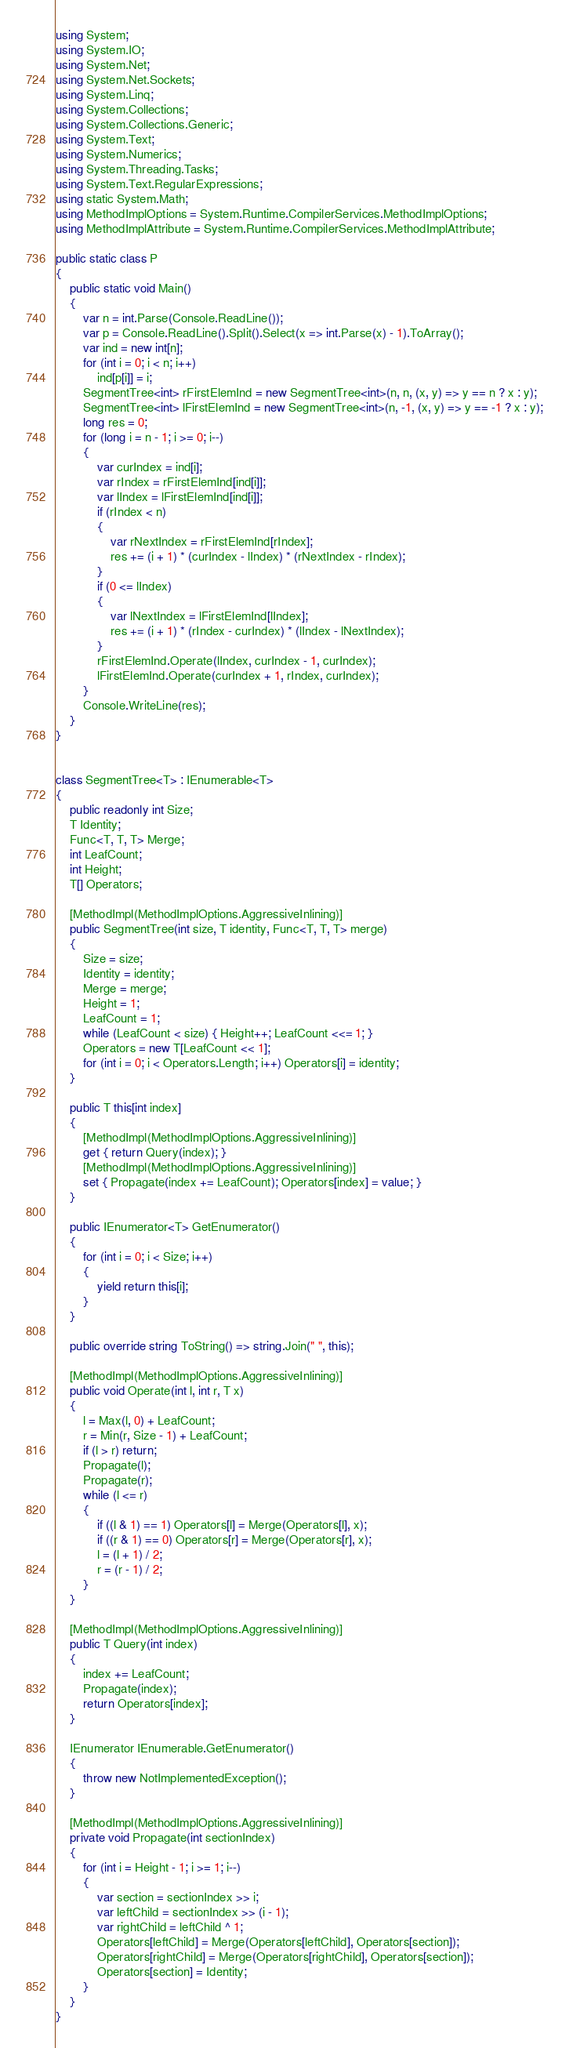Convert code to text. <code><loc_0><loc_0><loc_500><loc_500><_C#_>using System;
using System.IO;
using System.Net;
using System.Net.Sockets;
using System.Linq;
using System.Collections;
using System.Collections.Generic;
using System.Text;
using System.Numerics;
using System.Threading.Tasks;
using System.Text.RegularExpressions;
using static System.Math;
using MethodImplOptions = System.Runtime.CompilerServices.MethodImplOptions;
using MethodImplAttribute = System.Runtime.CompilerServices.MethodImplAttribute;

public static class P
{
    public static void Main()
    {
        var n = int.Parse(Console.ReadLine());
        var p = Console.ReadLine().Split().Select(x => int.Parse(x) - 1).ToArray();
        var ind = new int[n];
        for (int i = 0; i < n; i++)
            ind[p[i]] = i;
        SegmentTree<int> rFirstElemInd = new SegmentTree<int>(n, n, (x, y) => y == n ? x : y);
        SegmentTree<int> lFirstElemInd = new SegmentTree<int>(n, -1, (x, y) => y == -1 ? x : y);
        long res = 0;
        for (long i = n - 1; i >= 0; i--)
        {
            var curIndex = ind[i];
            var rIndex = rFirstElemInd[ind[i]];
            var lIndex = lFirstElemInd[ind[i]];
            if (rIndex < n)
            {
                var rNextIndex = rFirstElemInd[rIndex];
                res += (i + 1) * (curIndex - lIndex) * (rNextIndex - rIndex);
            }
            if (0 <= lIndex)
            {
                var lNextIndex = lFirstElemInd[lIndex];
                res += (i + 1) * (rIndex - curIndex) * (lIndex - lNextIndex);
            }
            rFirstElemInd.Operate(lIndex, curIndex - 1, curIndex);
            lFirstElemInd.Operate(curIndex + 1, rIndex, curIndex);
        }
        Console.WriteLine(res);
    }
}


class SegmentTree<T> : IEnumerable<T>
{
    public readonly int Size;
    T Identity;
    Func<T, T, T> Merge;
    int LeafCount;
    int Height;
    T[] Operators;

    [MethodImpl(MethodImplOptions.AggressiveInlining)]
    public SegmentTree(int size, T identity, Func<T, T, T> merge)
    {
        Size = size;
        Identity = identity;
        Merge = merge;
        Height = 1;
        LeafCount = 1;
        while (LeafCount < size) { Height++; LeafCount <<= 1; }
        Operators = new T[LeafCount << 1];
        for (int i = 0; i < Operators.Length; i++) Operators[i] = identity;
    }

    public T this[int index]
    {
        [MethodImpl(MethodImplOptions.AggressiveInlining)]
        get { return Query(index); }
        [MethodImpl(MethodImplOptions.AggressiveInlining)]
        set { Propagate(index += LeafCount); Operators[index] = value; }
    }

    public IEnumerator<T> GetEnumerator()
    {
        for (int i = 0; i < Size; i++)
        {
            yield return this[i];
        }
    }

    public override string ToString() => string.Join(" ", this);

    [MethodImpl(MethodImplOptions.AggressiveInlining)]
    public void Operate(int l, int r, T x)
    {
        l = Max(l, 0) + LeafCount;
        r = Min(r, Size - 1) + LeafCount;
        if (l > r) return;
        Propagate(l);
        Propagate(r);
        while (l <= r)
        {
            if ((l & 1) == 1) Operators[l] = Merge(Operators[l], x);
            if ((r & 1) == 0) Operators[r] = Merge(Operators[r], x);
            l = (l + 1) / 2;
            r = (r - 1) / 2;
        }
    }

    [MethodImpl(MethodImplOptions.AggressiveInlining)]
    public T Query(int index)
    {
        index += LeafCount;
        Propagate(index);
        return Operators[index];
    }

    IEnumerator IEnumerable.GetEnumerator()
    {
        throw new NotImplementedException();
    }

    [MethodImpl(MethodImplOptions.AggressiveInlining)]
    private void Propagate(int sectionIndex)
    {
        for (int i = Height - 1; i >= 1; i--)
        {
            var section = sectionIndex >> i;
            var leftChild = sectionIndex >> (i - 1);
            var rightChild = leftChild ^ 1;
            Operators[leftChild] = Merge(Operators[leftChild], Operators[section]);
            Operators[rightChild] = Merge(Operators[rightChild], Operators[section]);
            Operators[section] = Identity;
        }
    }
}

</code> 